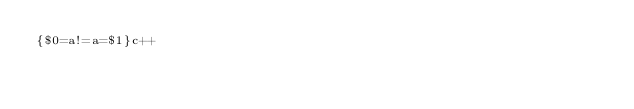Convert code to text. <code><loc_0><loc_0><loc_500><loc_500><_Awk_>{$0=a!=a=$1}c++</code> 